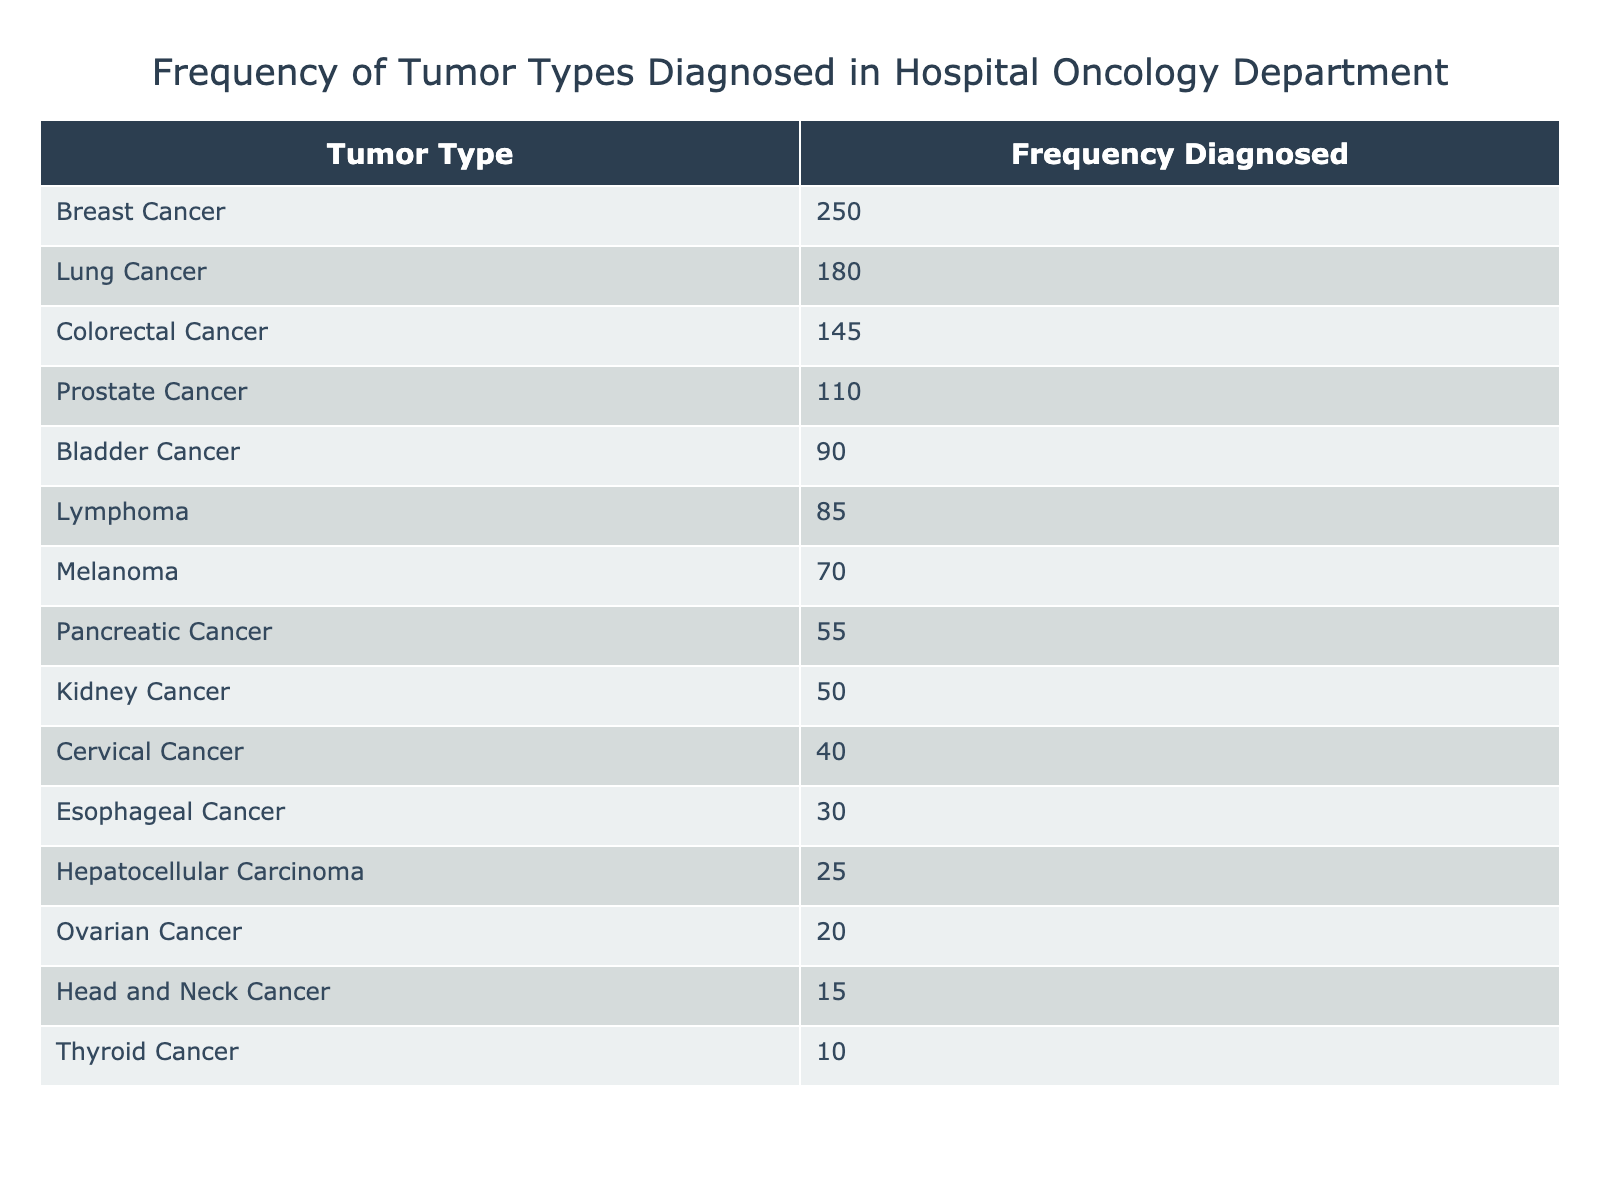What is the most frequently diagnosed tumor type? The table lists the tumor types diagnosed and their corresponding frequencies. The tumor type with the highest frequency is at the top of the table, which is Breast Cancer with a frequency of 250.
Answer: Breast Cancer How many cases of Lung Cancer were diagnosed? Lung Cancer is listed in the table with an associated frequency of 180, which is directly taken from the provided data.
Answer: 180 What is the total frequency of Colorectal Cancer and Prostate Cancer diagnosed? To find the total, we add the frequencies of Colorectal Cancer (145) and Prostate Cancer (110). So, 145 + 110 = 255 cases were diagnosed for both types combined.
Answer: 255 Is there more than one type of cancer diagnosed at a frequency of more than 100? Checking the frequencies in the table, we find several tumor types have frequencies greater than 100, specifically Breast Cancer, Lung Cancer, and Colorectal Cancer. Thus, yes, there are multiple types diagnosed with this frequency.
Answer: Yes What is the difference in frequency between the most and least diagnosed tumor types? The most diagnosed tumor type is Breast Cancer with 250 cases, and the least diagnosed is Thyroid Cancer with 10 cases. The difference can be calculated as 250 - 10 = 240.
Answer: 240 What is the average frequency of the top three diagnosed tumor types? The top three diagnosed tumor types are Breast Cancer (250), Lung Cancer (180), and Colorectal Cancer (145). To find the average, we sum these frequencies (250 + 180 + 145 = 575) and divide by 3, which gives us an average of 575 / 3 = 191.67.
Answer: 191.67 Is Pancreatic Cancer diagnosed more frequently than Ovarian Cancer? The frequency for Pancreatic Cancer is 55, while for Ovarian Cancer it is 20. Since 55 is greater than 20, the statement is true.
Answer: Yes What percentage of the diagnosed cases were for Breast Cancer? The total frequency of all tumor types is 250 + 180 + 145 + 110 + 90 + 85 + 70 + 55 + 50 + 40 + 30 + 25 + 20 + 15 + 10 = 1,225. The frequency for Breast Cancer is 250. To find the percentage, the calculation is (250 / 1225) * 100 ≈ 20.41%.
Answer: 20.41% How many tumor types were diagnosed less frequently than Kidney Cancer? Kidney Cancer has a frequency of 50. Looking at the table, we see six types of cancer diagnosed less frequently than this (Cervical, Esophageal, Hepatocellular, Ovarian, Head and Neck, and Thyroid Cancer). Therefore, there are six tumor types diagnosed at a frequency lower than 50.
Answer: 6 